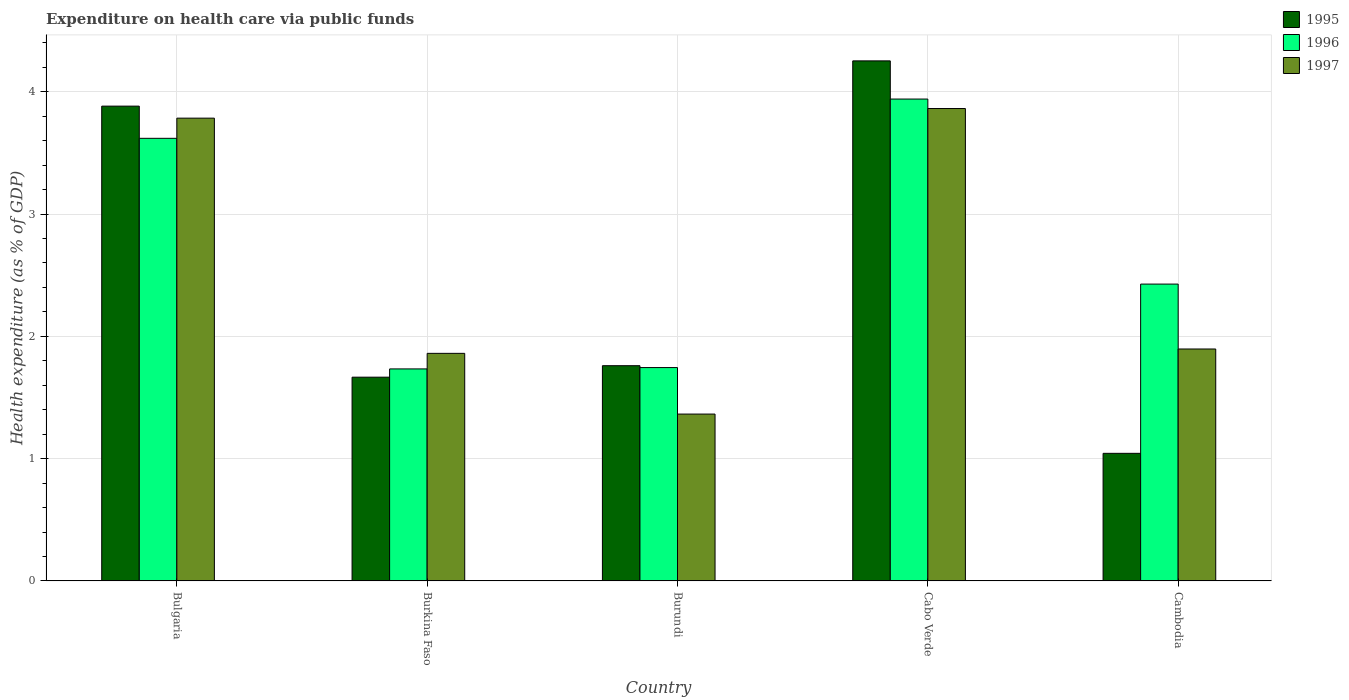How many groups of bars are there?
Give a very brief answer. 5. Are the number of bars on each tick of the X-axis equal?
Your answer should be compact. Yes. How many bars are there on the 4th tick from the left?
Your answer should be compact. 3. What is the label of the 3rd group of bars from the left?
Ensure brevity in your answer.  Burundi. What is the expenditure made on health care in 1996 in Bulgaria?
Provide a succinct answer. 3.62. Across all countries, what is the maximum expenditure made on health care in 1997?
Make the answer very short. 3.86. Across all countries, what is the minimum expenditure made on health care in 1997?
Keep it short and to the point. 1.36. In which country was the expenditure made on health care in 1995 maximum?
Keep it short and to the point. Cabo Verde. In which country was the expenditure made on health care in 1997 minimum?
Your response must be concise. Burundi. What is the total expenditure made on health care in 1995 in the graph?
Make the answer very short. 12.6. What is the difference between the expenditure made on health care in 1997 in Burkina Faso and that in Burundi?
Your answer should be compact. 0.5. What is the difference between the expenditure made on health care in 1997 in Burundi and the expenditure made on health care in 1996 in Cambodia?
Keep it short and to the point. -1.06. What is the average expenditure made on health care in 1997 per country?
Your response must be concise. 2.55. What is the difference between the expenditure made on health care of/in 1995 and expenditure made on health care of/in 1997 in Cambodia?
Provide a succinct answer. -0.85. What is the ratio of the expenditure made on health care in 1995 in Bulgaria to that in Burundi?
Provide a short and direct response. 2.21. Is the expenditure made on health care in 1995 in Burkina Faso less than that in Cambodia?
Offer a terse response. No. Is the difference between the expenditure made on health care in 1995 in Bulgaria and Cabo Verde greater than the difference between the expenditure made on health care in 1997 in Bulgaria and Cabo Verde?
Ensure brevity in your answer.  No. What is the difference between the highest and the second highest expenditure made on health care in 1995?
Offer a terse response. -2.12. What is the difference between the highest and the lowest expenditure made on health care in 1995?
Keep it short and to the point. 3.21. In how many countries, is the expenditure made on health care in 1996 greater than the average expenditure made on health care in 1996 taken over all countries?
Offer a very short reply. 2. What does the 2nd bar from the left in Cabo Verde represents?
Your response must be concise. 1996. Is it the case that in every country, the sum of the expenditure made on health care in 1996 and expenditure made on health care in 1995 is greater than the expenditure made on health care in 1997?
Make the answer very short. Yes. How many bars are there?
Keep it short and to the point. 15. Are all the bars in the graph horizontal?
Offer a very short reply. No. How many countries are there in the graph?
Keep it short and to the point. 5. What is the difference between two consecutive major ticks on the Y-axis?
Provide a short and direct response. 1. Are the values on the major ticks of Y-axis written in scientific E-notation?
Give a very brief answer. No. Does the graph contain grids?
Your response must be concise. Yes. Where does the legend appear in the graph?
Your response must be concise. Top right. How many legend labels are there?
Your answer should be very brief. 3. How are the legend labels stacked?
Offer a very short reply. Vertical. What is the title of the graph?
Offer a very short reply. Expenditure on health care via public funds. What is the label or title of the Y-axis?
Your answer should be compact. Health expenditure (as % of GDP). What is the Health expenditure (as % of GDP) of 1995 in Bulgaria?
Keep it short and to the point. 3.88. What is the Health expenditure (as % of GDP) in 1996 in Bulgaria?
Your answer should be compact. 3.62. What is the Health expenditure (as % of GDP) of 1997 in Bulgaria?
Provide a succinct answer. 3.78. What is the Health expenditure (as % of GDP) in 1995 in Burkina Faso?
Offer a terse response. 1.67. What is the Health expenditure (as % of GDP) of 1996 in Burkina Faso?
Offer a terse response. 1.73. What is the Health expenditure (as % of GDP) of 1997 in Burkina Faso?
Your answer should be very brief. 1.86. What is the Health expenditure (as % of GDP) in 1995 in Burundi?
Provide a short and direct response. 1.76. What is the Health expenditure (as % of GDP) of 1996 in Burundi?
Offer a very short reply. 1.74. What is the Health expenditure (as % of GDP) of 1997 in Burundi?
Ensure brevity in your answer.  1.36. What is the Health expenditure (as % of GDP) of 1995 in Cabo Verde?
Provide a short and direct response. 4.25. What is the Health expenditure (as % of GDP) of 1996 in Cabo Verde?
Ensure brevity in your answer.  3.94. What is the Health expenditure (as % of GDP) in 1997 in Cabo Verde?
Your answer should be very brief. 3.86. What is the Health expenditure (as % of GDP) of 1995 in Cambodia?
Make the answer very short. 1.04. What is the Health expenditure (as % of GDP) of 1996 in Cambodia?
Provide a succinct answer. 2.43. What is the Health expenditure (as % of GDP) of 1997 in Cambodia?
Your answer should be very brief. 1.9. Across all countries, what is the maximum Health expenditure (as % of GDP) in 1995?
Your response must be concise. 4.25. Across all countries, what is the maximum Health expenditure (as % of GDP) of 1996?
Your answer should be very brief. 3.94. Across all countries, what is the maximum Health expenditure (as % of GDP) in 1997?
Ensure brevity in your answer.  3.86. Across all countries, what is the minimum Health expenditure (as % of GDP) in 1995?
Provide a succinct answer. 1.04. Across all countries, what is the minimum Health expenditure (as % of GDP) of 1996?
Keep it short and to the point. 1.73. Across all countries, what is the minimum Health expenditure (as % of GDP) in 1997?
Keep it short and to the point. 1.36. What is the total Health expenditure (as % of GDP) in 1995 in the graph?
Give a very brief answer. 12.6. What is the total Health expenditure (as % of GDP) in 1996 in the graph?
Provide a short and direct response. 13.46. What is the total Health expenditure (as % of GDP) in 1997 in the graph?
Provide a succinct answer. 12.77. What is the difference between the Health expenditure (as % of GDP) of 1995 in Bulgaria and that in Burkina Faso?
Offer a very short reply. 2.22. What is the difference between the Health expenditure (as % of GDP) in 1996 in Bulgaria and that in Burkina Faso?
Offer a terse response. 1.89. What is the difference between the Health expenditure (as % of GDP) of 1997 in Bulgaria and that in Burkina Faso?
Your answer should be very brief. 1.92. What is the difference between the Health expenditure (as % of GDP) in 1995 in Bulgaria and that in Burundi?
Your answer should be very brief. 2.12. What is the difference between the Health expenditure (as % of GDP) in 1996 in Bulgaria and that in Burundi?
Provide a short and direct response. 1.87. What is the difference between the Health expenditure (as % of GDP) of 1997 in Bulgaria and that in Burundi?
Provide a succinct answer. 2.42. What is the difference between the Health expenditure (as % of GDP) of 1995 in Bulgaria and that in Cabo Verde?
Keep it short and to the point. -0.37. What is the difference between the Health expenditure (as % of GDP) of 1996 in Bulgaria and that in Cabo Verde?
Give a very brief answer. -0.32. What is the difference between the Health expenditure (as % of GDP) in 1997 in Bulgaria and that in Cabo Verde?
Provide a short and direct response. -0.08. What is the difference between the Health expenditure (as % of GDP) of 1995 in Bulgaria and that in Cambodia?
Make the answer very short. 2.84. What is the difference between the Health expenditure (as % of GDP) of 1996 in Bulgaria and that in Cambodia?
Keep it short and to the point. 1.19. What is the difference between the Health expenditure (as % of GDP) of 1997 in Bulgaria and that in Cambodia?
Your answer should be very brief. 1.89. What is the difference between the Health expenditure (as % of GDP) of 1995 in Burkina Faso and that in Burundi?
Your answer should be compact. -0.09. What is the difference between the Health expenditure (as % of GDP) in 1996 in Burkina Faso and that in Burundi?
Offer a terse response. -0.01. What is the difference between the Health expenditure (as % of GDP) of 1997 in Burkina Faso and that in Burundi?
Provide a succinct answer. 0.5. What is the difference between the Health expenditure (as % of GDP) of 1995 in Burkina Faso and that in Cabo Verde?
Your response must be concise. -2.59. What is the difference between the Health expenditure (as % of GDP) in 1996 in Burkina Faso and that in Cabo Verde?
Offer a terse response. -2.21. What is the difference between the Health expenditure (as % of GDP) in 1997 in Burkina Faso and that in Cabo Verde?
Offer a very short reply. -2. What is the difference between the Health expenditure (as % of GDP) of 1995 in Burkina Faso and that in Cambodia?
Give a very brief answer. 0.62. What is the difference between the Health expenditure (as % of GDP) of 1996 in Burkina Faso and that in Cambodia?
Make the answer very short. -0.69. What is the difference between the Health expenditure (as % of GDP) in 1997 in Burkina Faso and that in Cambodia?
Make the answer very short. -0.04. What is the difference between the Health expenditure (as % of GDP) of 1995 in Burundi and that in Cabo Verde?
Provide a succinct answer. -2.49. What is the difference between the Health expenditure (as % of GDP) of 1996 in Burundi and that in Cabo Verde?
Your answer should be compact. -2.2. What is the difference between the Health expenditure (as % of GDP) in 1997 in Burundi and that in Cabo Verde?
Give a very brief answer. -2.5. What is the difference between the Health expenditure (as % of GDP) of 1995 in Burundi and that in Cambodia?
Make the answer very short. 0.72. What is the difference between the Health expenditure (as % of GDP) in 1996 in Burundi and that in Cambodia?
Your answer should be compact. -0.68. What is the difference between the Health expenditure (as % of GDP) in 1997 in Burundi and that in Cambodia?
Your answer should be very brief. -0.53. What is the difference between the Health expenditure (as % of GDP) of 1995 in Cabo Verde and that in Cambodia?
Your answer should be compact. 3.21. What is the difference between the Health expenditure (as % of GDP) in 1996 in Cabo Verde and that in Cambodia?
Provide a succinct answer. 1.51. What is the difference between the Health expenditure (as % of GDP) of 1997 in Cabo Verde and that in Cambodia?
Keep it short and to the point. 1.97. What is the difference between the Health expenditure (as % of GDP) of 1995 in Bulgaria and the Health expenditure (as % of GDP) of 1996 in Burkina Faso?
Provide a short and direct response. 2.15. What is the difference between the Health expenditure (as % of GDP) in 1995 in Bulgaria and the Health expenditure (as % of GDP) in 1997 in Burkina Faso?
Ensure brevity in your answer.  2.02. What is the difference between the Health expenditure (as % of GDP) in 1996 in Bulgaria and the Health expenditure (as % of GDP) in 1997 in Burkina Faso?
Offer a terse response. 1.76. What is the difference between the Health expenditure (as % of GDP) of 1995 in Bulgaria and the Health expenditure (as % of GDP) of 1996 in Burundi?
Your answer should be compact. 2.14. What is the difference between the Health expenditure (as % of GDP) in 1995 in Bulgaria and the Health expenditure (as % of GDP) in 1997 in Burundi?
Make the answer very short. 2.52. What is the difference between the Health expenditure (as % of GDP) in 1996 in Bulgaria and the Health expenditure (as % of GDP) in 1997 in Burundi?
Provide a short and direct response. 2.25. What is the difference between the Health expenditure (as % of GDP) in 1995 in Bulgaria and the Health expenditure (as % of GDP) in 1996 in Cabo Verde?
Give a very brief answer. -0.06. What is the difference between the Health expenditure (as % of GDP) in 1995 in Bulgaria and the Health expenditure (as % of GDP) in 1997 in Cabo Verde?
Make the answer very short. 0.02. What is the difference between the Health expenditure (as % of GDP) in 1996 in Bulgaria and the Health expenditure (as % of GDP) in 1997 in Cabo Verde?
Your answer should be compact. -0.24. What is the difference between the Health expenditure (as % of GDP) of 1995 in Bulgaria and the Health expenditure (as % of GDP) of 1996 in Cambodia?
Offer a very short reply. 1.46. What is the difference between the Health expenditure (as % of GDP) of 1995 in Bulgaria and the Health expenditure (as % of GDP) of 1997 in Cambodia?
Your answer should be compact. 1.99. What is the difference between the Health expenditure (as % of GDP) of 1996 in Bulgaria and the Health expenditure (as % of GDP) of 1997 in Cambodia?
Your response must be concise. 1.72. What is the difference between the Health expenditure (as % of GDP) in 1995 in Burkina Faso and the Health expenditure (as % of GDP) in 1996 in Burundi?
Offer a very short reply. -0.08. What is the difference between the Health expenditure (as % of GDP) in 1995 in Burkina Faso and the Health expenditure (as % of GDP) in 1997 in Burundi?
Provide a succinct answer. 0.3. What is the difference between the Health expenditure (as % of GDP) in 1996 in Burkina Faso and the Health expenditure (as % of GDP) in 1997 in Burundi?
Provide a short and direct response. 0.37. What is the difference between the Health expenditure (as % of GDP) in 1995 in Burkina Faso and the Health expenditure (as % of GDP) in 1996 in Cabo Verde?
Offer a terse response. -2.27. What is the difference between the Health expenditure (as % of GDP) in 1995 in Burkina Faso and the Health expenditure (as % of GDP) in 1997 in Cabo Verde?
Offer a terse response. -2.2. What is the difference between the Health expenditure (as % of GDP) of 1996 in Burkina Faso and the Health expenditure (as % of GDP) of 1997 in Cabo Verde?
Ensure brevity in your answer.  -2.13. What is the difference between the Health expenditure (as % of GDP) of 1995 in Burkina Faso and the Health expenditure (as % of GDP) of 1996 in Cambodia?
Offer a terse response. -0.76. What is the difference between the Health expenditure (as % of GDP) in 1995 in Burkina Faso and the Health expenditure (as % of GDP) in 1997 in Cambodia?
Provide a succinct answer. -0.23. What is the difference between the Health expenditure (as % of GDP) of 1996 in Burkina Faso and the Health expenditure (as % of GDP) of 1997 in Cambodia?
Offer a very short reply. -0.16. What is the difference between the Health expenditure (as % of GDP) in 1995 in Burundi and the Health expenditure (as % of GDP) in 1996 in Cabo Verde?
Provide a short and direct response. -2.18. What is the difference between the Health expenditure (as % of GDP) of 1995 in Burundi and the Health expenditure (as % of GDP) of 1997 in Cabo Verde?
Offer a very short reply. -2.1. What is the difference between the Health expenditure (as % of GDP) of 1996 in Burundi and the Health expenditure (as % of GDP) of 1997 in Cabo Verde?
Your response must be concise. -2.12. What is the difference between the Health expenditure (as % of GDP) of 1995 in Burundi and the Health expenditure (as % of GDP) of 1996 in Cambodia?
Your answer should be compact. -0.67. What is the difference between the Health expenditure (as % of GDP) in 1995 in Burundi and the Health expenditure (as % of GDP) in 1997 in Cambodia?
Give a very brief answer. -0.14. What is the difference between the Health expenditure (as % of GDP) in 1996 in Burundi and the Health expenditure (as % of GDP) in 1997 in Cambodia?
Provide a succinct answer. -0.15. What is the difference between the Health expenditure (as % of GDP) of 1995 in Cabo Verde and the Health expenditure (as % of GDP) of 1996 in Cambodia?
Provide a succinct answer. 1.83. What is the difference between the Health expenditure (as % of GDP) in 1995 in Cabo Verde and the Health expenditure (as % of GDP) in 1997 in Cambodia?
Provide a succinct answer. 2.36. What is the difference between the Health expenditure (as % of GDP) of 1996 in Cabo Verde and the Health expenditure (as % of GDP) of 1997 in Cambodia?
Your answer should be very brief. 2.04. What is the average Health expenditure (as % of GDP) of 1995 per country?
Your response must be concise. 2.52. What is the average Health expenditure (as % of GDP) in 1996 per country?
Give a very brief answer. 2.69. What is the average Health expenditure (as % of GDP) of 1997 per country?
Your answer should be very brief. 2.55. What is the difference between the Health expenditure (as % of GDP) of 1995 and Health expenditure (as % of GDP) of 1996 in Bulgaria?
Provide a short and direct response. 0.26. What is the difference between the Health expenditure (as % of GDP) of 1995 and Health expenditure (as % of GDP) of 1997 in Bulgaria?
Provide a short and direct response. 0.1. What is the difference between the Health expenditure (as % of GDP) of 1996 and Health expenditure (as % of GDP) of 1997 in Bulgaria?
Keep it short and to the point. -0.16. What is the difference between the Health expenditure (as % of GDP) of 1995 and Health expenditure (as % of GDP) of 1996 in Burkina Faso?
Give a very brief answer. -0.07. What is the difference between the Health expenditure (as % of GDP) of 1995 and Health expenditure (as % of GDP) of 1997 in Burkina Faso?
Make the answer very short. -0.19. What is the difference between the Health expenditure (as % of GDP) in 1996 and Health expenditure (as % of GDP) in 1997 in Burkina Faso?
Make the answer very short. -0.13. What is the difference between the Health expenditure (as % of GDP) in 1995 and Health expenditure (as % of GDP) in 1996 in Burundi?
Make the answer very short. 0.02. What is the difference between the Health expenditure (as % of GDP) in 1995 and Health expenditure (as % of GDP) in 1997 in Burundi?
Offer a very short reply. 0.4. What is the difference between the Health expenditure (as % of GDP) of 1996 and Health expenditure (as % of GDP) of 1997 in Burundi?
Your answer should be very brief. 0.38. What is the difference between the Health expenditure (as % of GDP) of 1995 and Health expenditure (as % of GDP) of 1996 in Cabo Verde?
Provide a short and direct response. 0.31. What is the difference between the Health expenditure (as % of GDP) of 1995 and Health expenditure (as % of GDP) of 1997 in Cabo Verde?
Provide a succinct answer. 0.39. What is the difference between the Health expenditure (as % of GDP) in 1996 and Health expenditure (as % of GDP) in 1997 in Cabo Verde?
Provide a short and direct response. 0.08. What is the difference between the Health expenditure (as % of GDP) in 1995 and Health expenditure (as % of GDP) in 1996 in Cambodia?
Provide a succinct answer. -1.38. What is the difference between the Health expenditure (as % of GDP) in 1995 and Health expenditure (as % of GDP) in 1997 in Cambodia?
Keep it short and to the point. -0.85. What is the difference between the Health expenditure (as % of GDP) of 1996 and Health expenditure (as % of GDP) of 1997 in Cambodia?
Give a very brief answer. 0.53. What is the ratio of the Health expenditure (as % of GDP) in 1995 in Bulgaria to that in Burkina Faso?
Provide a succinct answer. 2.33. What is the ratio of the Health expenditure (as % of GDP) in 1996 in Bulgaria to that in Burkina Faso?
Provide a succinct answer. 2.09. What is the ratio of the Health expenditure (as % of GDP) in 1997 in Bulgaria to that in Burkina Faso?
Give a very brief answer. 2.03. What is the ratio of the Health expenditure (as % of GDP) of 1995 in Bulgaria to that in Burundi?
Offer a very short reply. 2.21. What is the ratio of the Health expenditure (as % of GDP) of 1996 in Bulgaria to that in Burundi?
Ensure brevity in your answer.  2.07. What is the ratio of the Health expenditure (as % of GDP) of 1997 in Bulgaria to that in Burundi?
Provide a succinct answer. 2.77. What is the ratio of the Health expenditure (as % of GDP) in 1995 in Bulgaria to that in Cabo Verde?
Your answer should be very brief. 0.91. What is the ratio of the Health expenditure (as % of GDP) in 1996 in Bulgaria to that in Cabo Verde?
Ensure brevity in your answer.  0.92. What is the ratio of the Health expenditure (as % of GDP) of 1997 in Bulgaria to that in Cabo Verde?
Ensure brevity in your answer.  0.98. What is the ratio of the Health expenditure (as % of GDP) of 1995 in Bulgaria to that in Cambodia?
Keep it short and to the point. 3.72. What is the ratio of the Health expenditure (as % of GDP) of 1996 in Bulgaria to that in Cambodia?
Offer a very short reply. 1.49. What is the ratio of the Health expenditure (as % of GDP) of 1997 in Bulgaria to that in Cambodia?
Offer a very short reply. 2. What is the ratio of the Health expenditure (as % of GDP) in 1995 in Burkina Faso to that in Burundi?
Give a very brief answer. 0.95. What is the ratio of the Health expenditure (as % of GDP) in 1996 in Burkina Faso to that in Burundi?
Your answer should be very brief. 0.99. What is the ratio of the Health expenditure (as % of GDP) of 1997 in Burkina Faso to that in Burundi?
Provide a short and direct response. 1.36. What is the ratio of the Health expenditure (as % of GDP) of 1995 in Burkina Faso to that in Cabo Verde?
Offer a terse response. 0.39. What is the ratio of the Health expenditure (as % of GDP) in 1996 in Burkina Faso to that in Cabo Verde?
Your response must be concise. 0.44. What is the ratio of the Health expenditure (as % of GDP) of 1997 in Burkina Faso to that in Cabo Verde?
Give a very brief answer. 0.48. What is the ratio of the Health expenditure (as % of GDP) in 1995 in Burkina Faso to that in Cambodia?
Keep it short and to the point. 1.6. What is the ratio of the Health expenditure (as % of GDP) in 1996 in Burkina Faso to that in Cambodia?
Your answer should be compact. 0.71. What is the ratio of the Health expenditure (as % of GDP) in 1997 in Burkina Faso to that in Cambodia?
Your response must be concise. 0.98. What is the ratio of the Health expenditure (as % of GDP) of 1995 in Burundi to that in Cabo Verde?
Give a very brief answer. 0.41. What is the ratio of the Health expenditure (as % of GDP) in 1996 in Burundi to that in Cabo Verde?
Offer a very short reply. 0.44. What is the ratio of the Health expenditure (as % of GDP) in 1997 in Burundi to that in Cabo Verde?
Ensure brevity in your answer.  0.35. What is the ratio of the Health expenditure (as % of GDP) of 1995 in Burundi to that in Cambodia?
Offer a very short reply. 1.69. What is the ratio of the Health expenditure (as % of GDP) of 1996 in Burundi to that in Cambodia?
Provide a short and direct response. 0.72. What is the ratio of the Health expenditure (as % of GDP) of 1997 in Burundi to that in Cambodia?
Provide a short and direct response. 0.72. What is the ratio of the Health expenditure (as % of GDP) in 1995 in Cabo Verde to that in Cambodia?
Give a very brief answer. 4.08. What is the ratio of the Health expenditure (as % of GDP) in 1996 in Cabo Verde to that in Cambodia?
Your answer should be compact. 1.62. What is the ratio of the Health expenditure (as % of GDP) of 1997 in Cabo Verde to that in Cambodia?
Offer a very short reply. 2.04. What is the difference between the highest and the second highest Health expenditure (as % of GDP) in 1995?
Make the answer very short. 0.37. What is the difference between the highest and the second highest Health expenditure (as % of GDP) of 1996?
Provide a short and direct response. 0.32. What is the difference between the highest and the second highest Health expenditure (as % of GDP) in 1997?
Offer a terse response. 0.08. What is the difference between the highest and the lowest Health expenditure (as % of GDP) in 1995?
Keep it short and to the point. 3.21. What is the difference between the highest and the lowest Health expenditure (as % of GDP) in 1996?
Your answer should be very brief. 2.21. What is the difference between the highest and the lowest Health expenditure (as % of GDP) of 1997?
Ensure brevity in your answer.  2.5. 